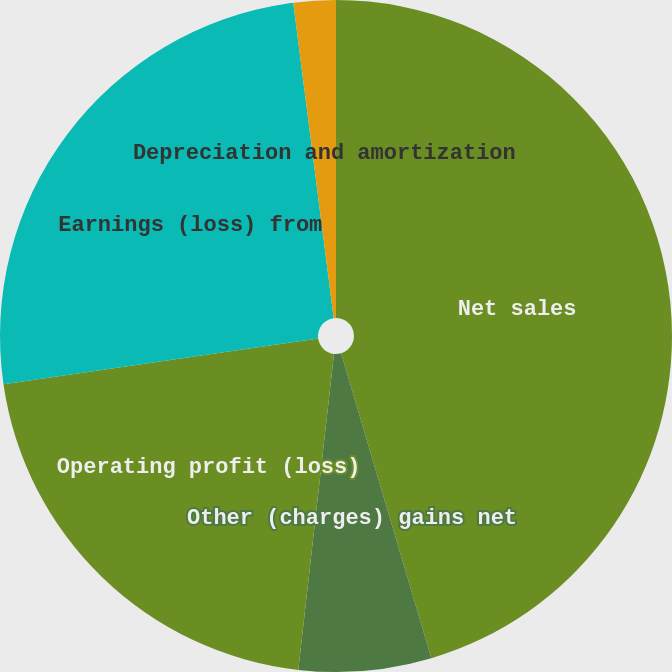Convert chart. <chart><loc_0><loc_0><loc_500><loc_500><pie_chart><fcel>Net sales<fcel>Other (charges) gains net<fcel>Operating profit (loss)<fcel>Earnings (loss) from<fcel>Depreciation and amortization<nl><fcel>45.42%<fcel>6.37%<fcel>20.92%<fcel>25.26%<fcel>2.03%<nl></chart> 